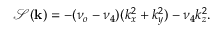<formula> <loc_0><loc_0><loc_500><loc_500>\mathcal { S } ( k ) = - ( \nu _ { o } - \nu _ { 4 } ) ( k _ { x } ^ { 2 } + k _ { y } ^ { 2 } ) - \nu _ { 4 } k _ { z } ^ { 2 } .</formula> 